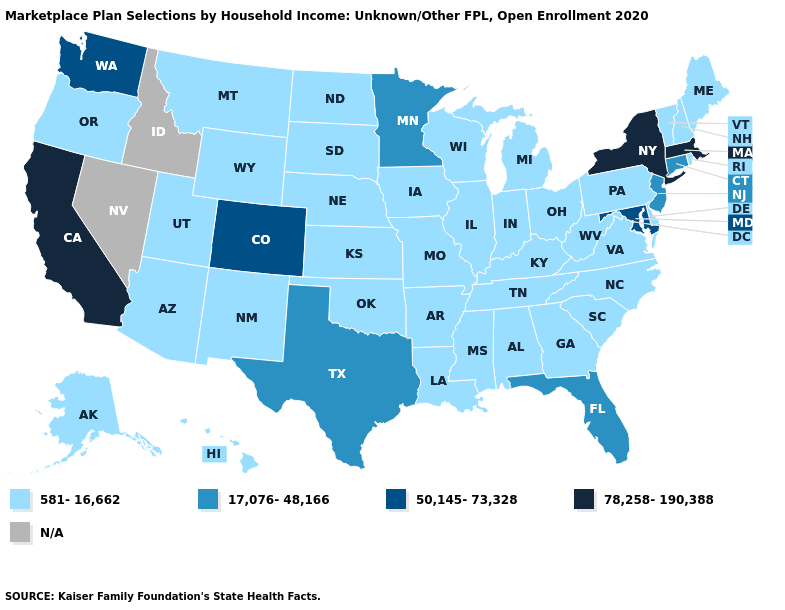Name the states that have a value in the range 50,145-73,328?
Write a very short answer. Colorado, Maryland, Washington. What is the value of South Carolina?
Write a very short answer. 581-16,662. Name the states that have a value in the range 581-16,662?
Be succinct. Alabama, Alaska, Arizona, Arkansas, Delaware, Georgia, Hawaii, Illinois, Indiana, Iowa, Kansas, Kentucky, Louisiana, Maine, Michigan, Mississippi, Missouri, Montana, Nebraska, New Hampshire, New Mexico, North Carolina, North Dakota, Ohio, Oklahoma, Oregon, Pennsylvania, Rhode Island, South Carolina, South Dakota, Tennessee, Utah, Vermont, Virginia, West Virginia, Wisconsin, Wyoming. What is the lowest value in the Northeast?
Give a very brief answer. 581-16,662. What is the highest value in the South ?
Quick response, please. 50,145-73,328. Does the first symbol in the legend represent the smallest category?
Write a very short answer. Yes. Is the legend a continuous bar?
Be succinct. No. What is the lowest value in the MidWest?
Quick response, please. 581-16,662. Among the states that border Nebraska , does Wyoming have the highest value?
Keep it brief. No. Name the states that have a value in the range N/A?
Give a very brief answer. Idaho, Nevada. Which states hav the highest value in the Northeast?
Short answer required. Massachusetts, New York. Does the map have missing data?
Concise answer only. Yes. What is the value of Rhode Island?
Quick response, please. 581-16,662. 